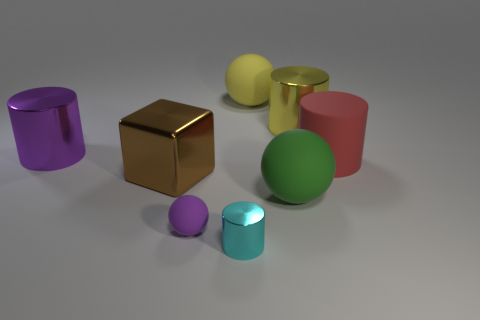There is a yellow object on the right side of the big yellow object that is to the left of the large green object; what is it made of?
Offer a terse response. Metal. Does the rubber object behind the purple cylinder have the same shape as the green thing?
Keep it short and to the point. Yes. Is the number of brown metallic things that are behind the red matte cylinder greater than the number of tiny red balls?
Offer a terse response. No. Is there any other thing that has the same material as the cyan cylinder?
Ensure brevity in your answer.  Yes. There is a metal thing that is the same color as the small matte sphere; what is its shape?
Offer a very short reply. Cylinder. How many blocks are either tiny cyan objects or big brown metal objects?
Keep it short and to the point. 1. There is a object behind the large metal cylinder on the right side of the small cyan metal cylinder; what is its color?
Give a very brief answer. Yellow. There is a cube; is it the same color as the large matte thing in front of the brown object?
Keep it short and to the point. No. What is the size of the other yellow cylinder that is made of the same material as the small cylinder?
Ensure brevity in your answer.  Large. What size is the metallic thing that is the same color as the tiny matte thing?
Your answer should be compact. Large. 